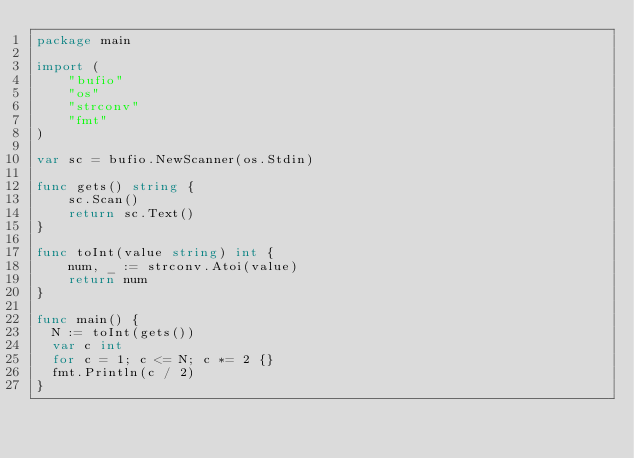Convert code to text. <code><loc_0><loc_0><loc_500><loc_500><_Go_>package main

import (
	"bufio"
	"os"
	"strconv"
  	"fmt"
)

var sc = bufio.NewScanner(os.Stdin)

func gets() string {
	sc.Scan()
	return sc.Text()
}

func toInt(value string) int {
	num, _ := strconv.Atoi(value)
	return num
}

func main() {
  N := toInt(gets())
  var c int
  for c = 1; c <= N; c *= 2 {}
  fmt.Println(c / 2)
}
</code> 